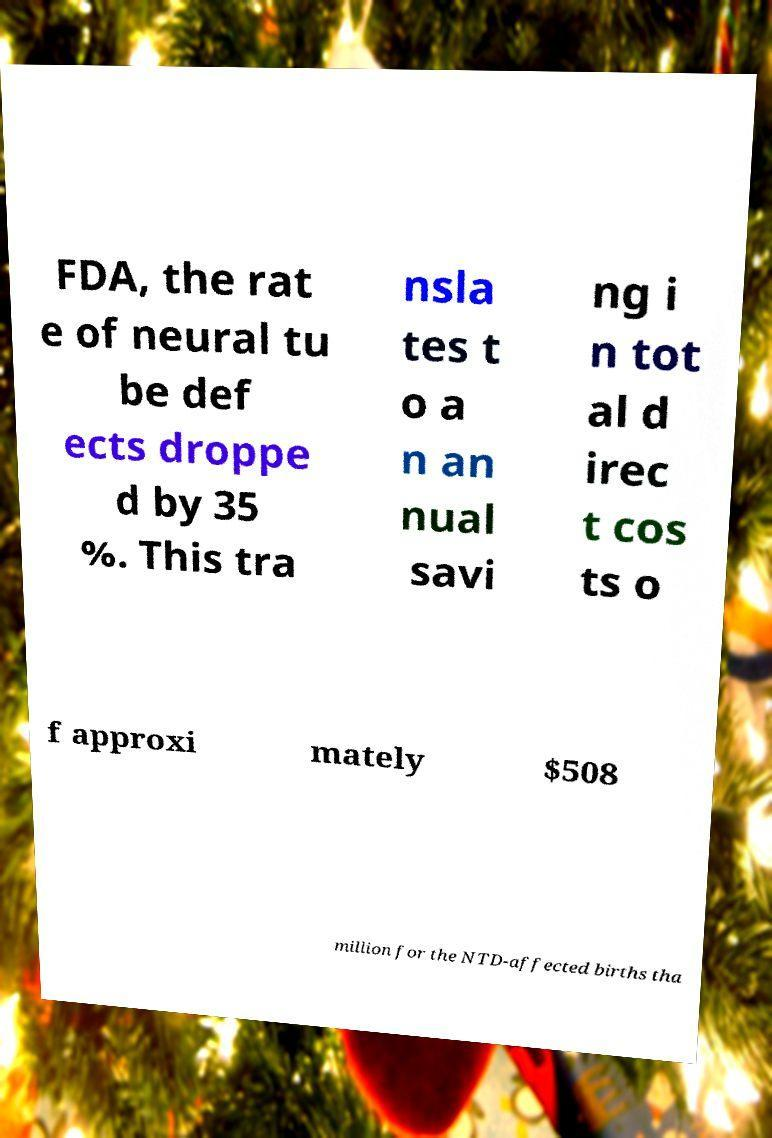For documentation purposes, I need the text within this image transcribed. Could you provide that? FDA, the rat e of neural tu be def ects droppe d by 35 %. This tra nsla tes t o a n an nual savi ng i n tot al d irec t cos ts o f approxi mately $508 million for the NTD-affected births tha 